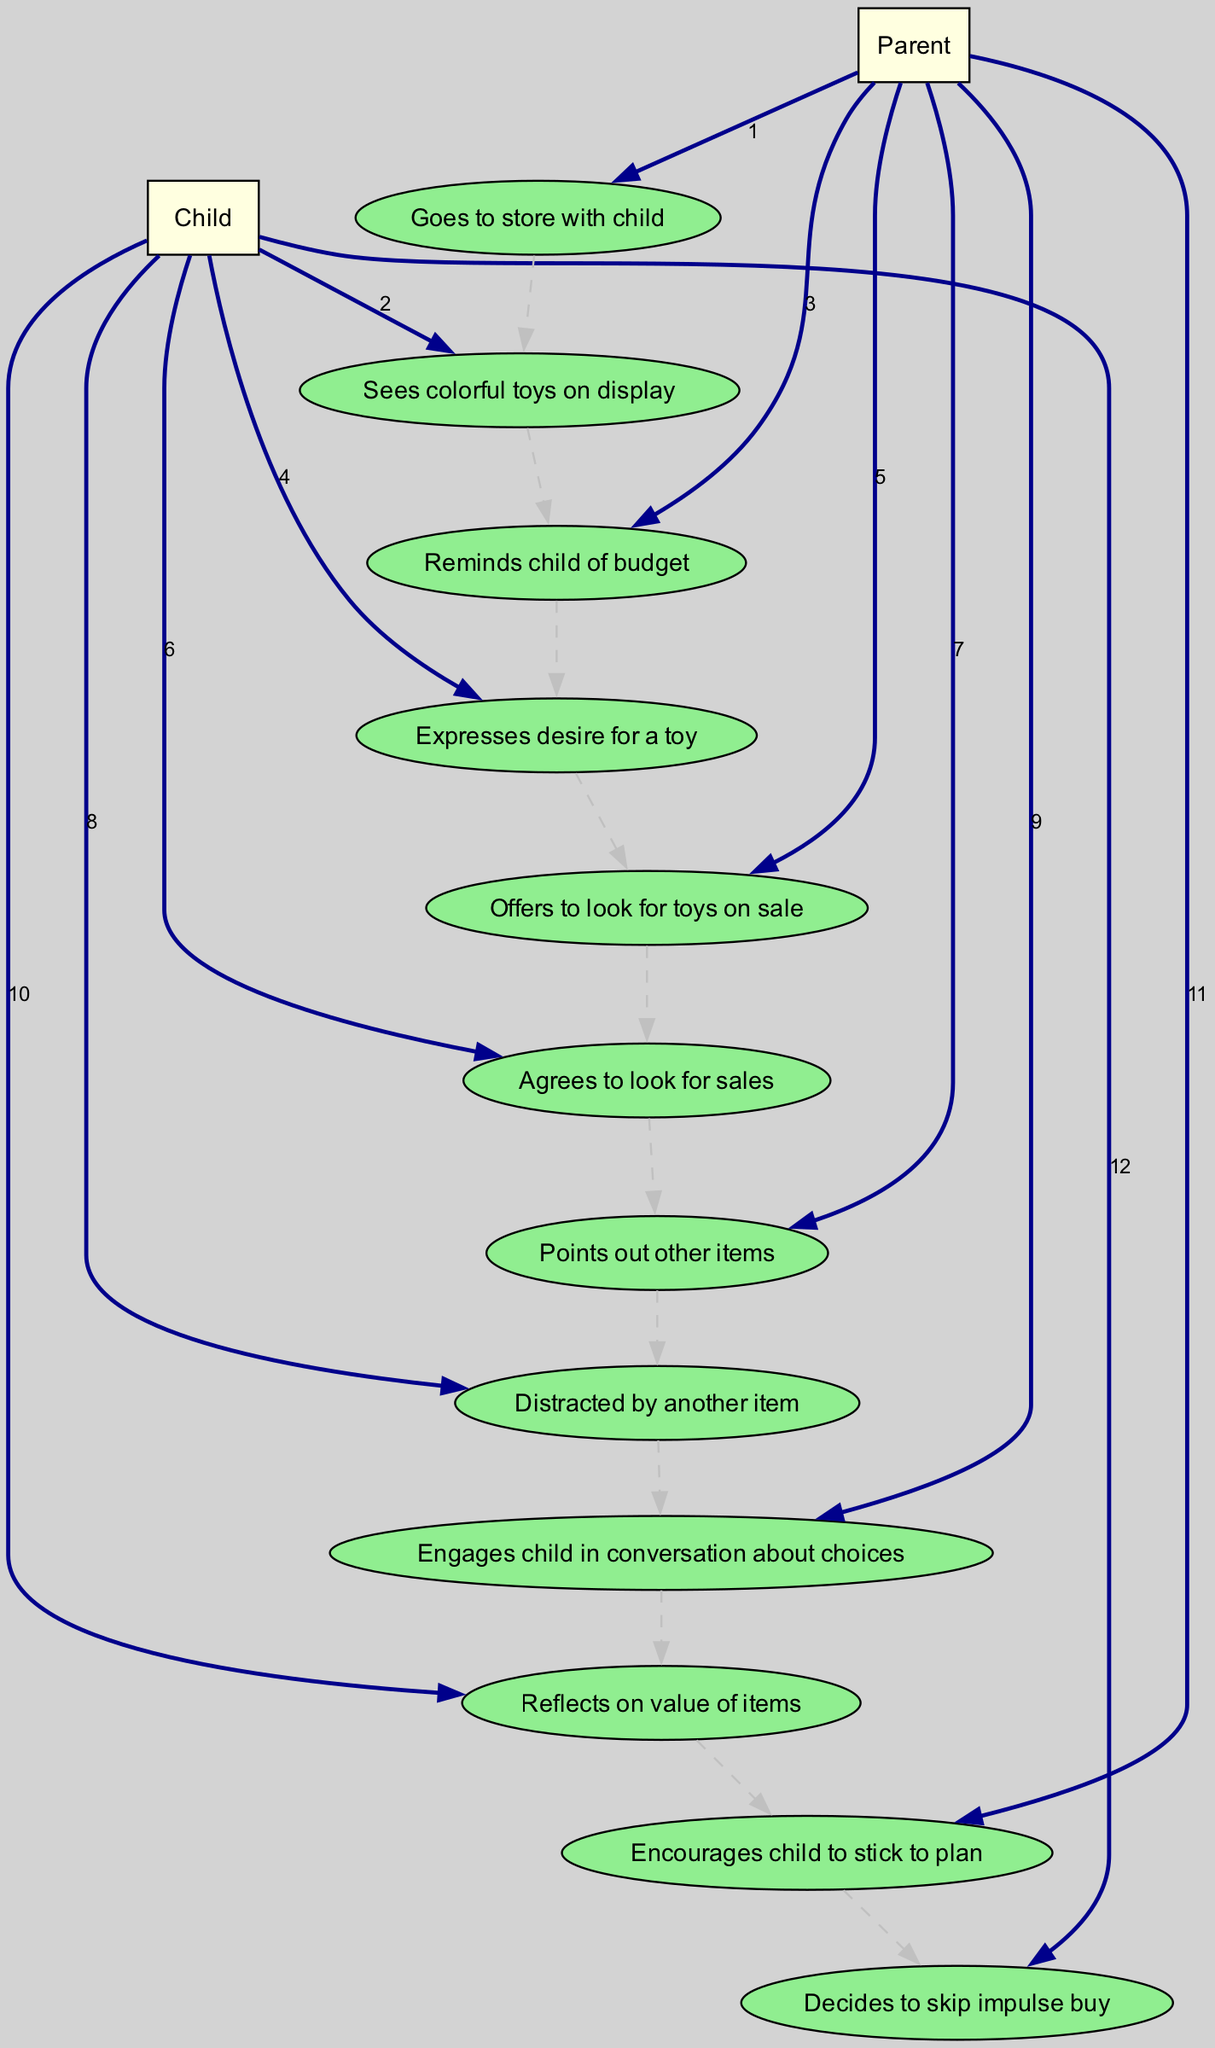What is the first action the Parent takes? The first action listed for the Parent in the diagram is "Goes to store with child." This is the initial step in the sequence of actions.
Answer: Goes to store with child How many actions does the Child take in total? The diagram shows a total of six actions attributed to the Child, as we count each instance where the Child has a specific action.
Answer: Six What does the Parent remind the Child of? The diagram specifies that the Parent reminds the Child of the "budget," indicating a key point in the conversation regarding spending.
Answer: Budget Which action follows the Child expressing a desire for a toy? After the Child expresses a desire for a toy, the next action in the sequence is the Parent offering to look for toys on sale, showing a supportive response.
Answer: Offers to look for toys on sale What is the last action taken by the Child? The last action taken by the Child is deciding to "skip impulse buy," concluding the sequence on a positive note highlighting self-control.
Answer: Decides to skip impulse buy After the Parent points out other items, what does the Child do next? Following the Parent pointing out other items, the Child becomes "Distracted by another item," indicating a moment of temptation that needs addressing.
Answer: Distracted by another item How many different actors are represented in this diagram? The diagram features two distinct actors: the Parent and the Child, each contributing to the dynamic of the shopping trip.
Answer: Two What does the Parent encourage the Child to do? The Parent encourages the Child to "stick to plan," emphasizing the importance of adhering to their original shopping intentions amidst distractions.
Answer: Stick to plan What does the Child reflect on after engaging in conversation about choices? After the conversation with the Parent, the Child reflects on the "value of items," indicating thoughtful consideration of what they are tempted to purchase.
Answer: Value of items 